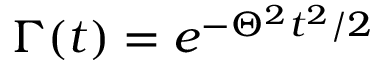Convert formula to latex. <formula><loc_0><loc_0><loc_500><loc_500>\Gamma ( t ) = e ^ { - \Theta ^ { 2 } t ^ { 2 } / 2 }</formula> 